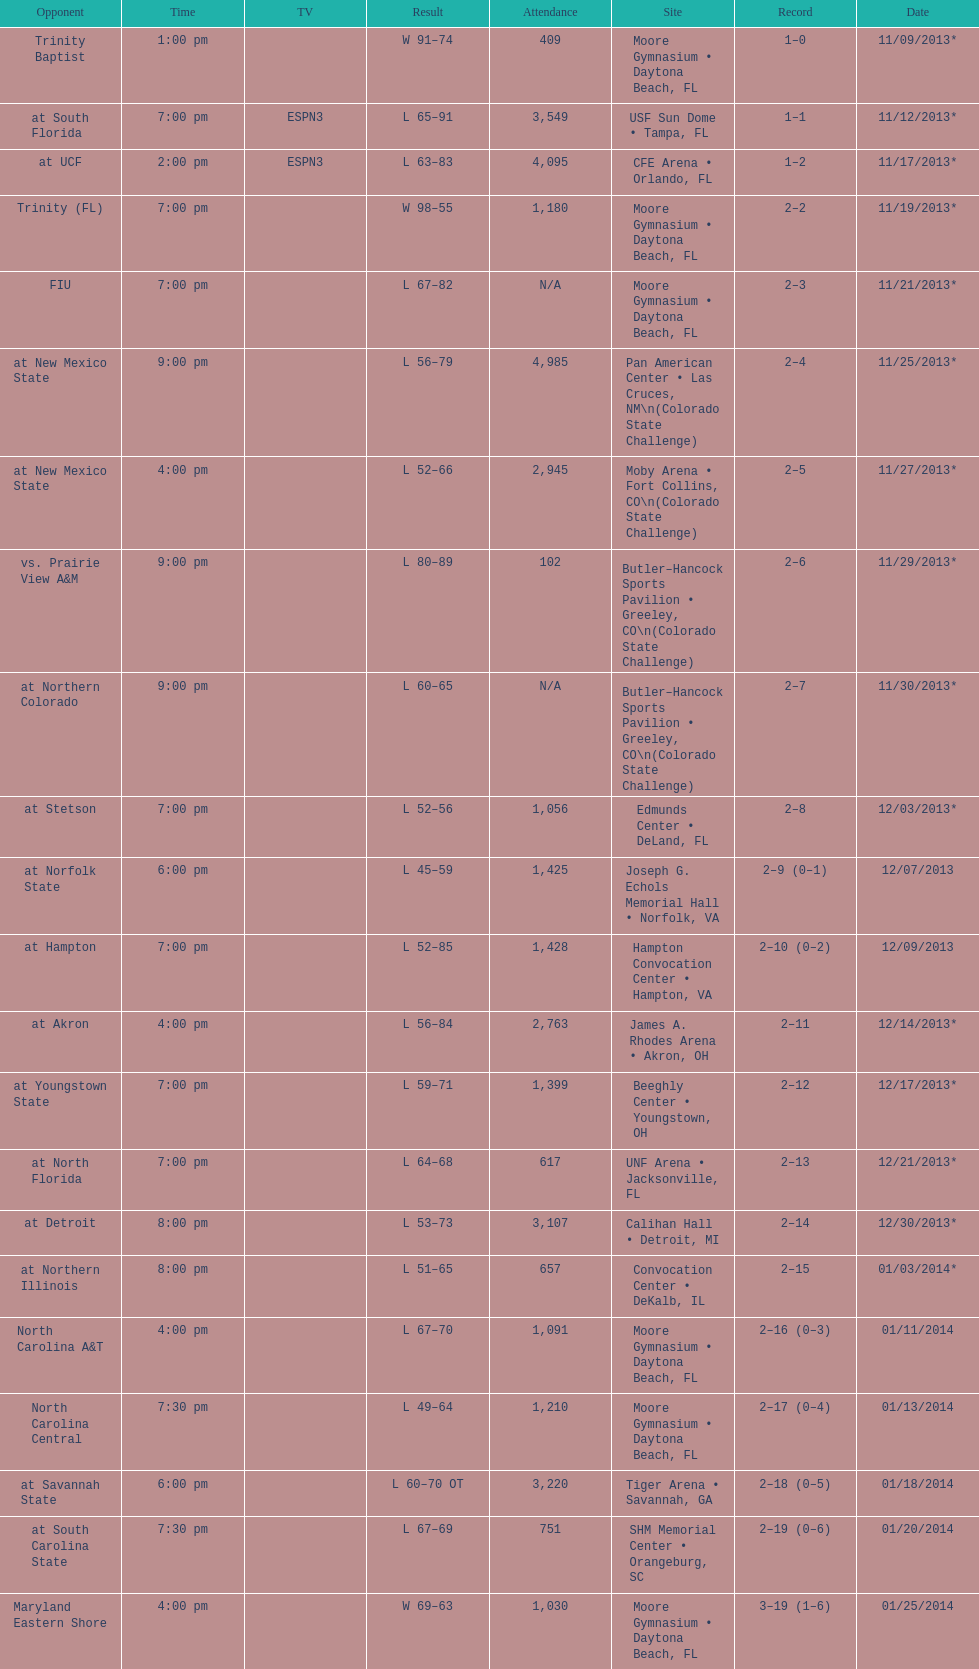Which game was won by a bigger margin, against trinity (fl) or against trinity baptist? Trinity (FL). 